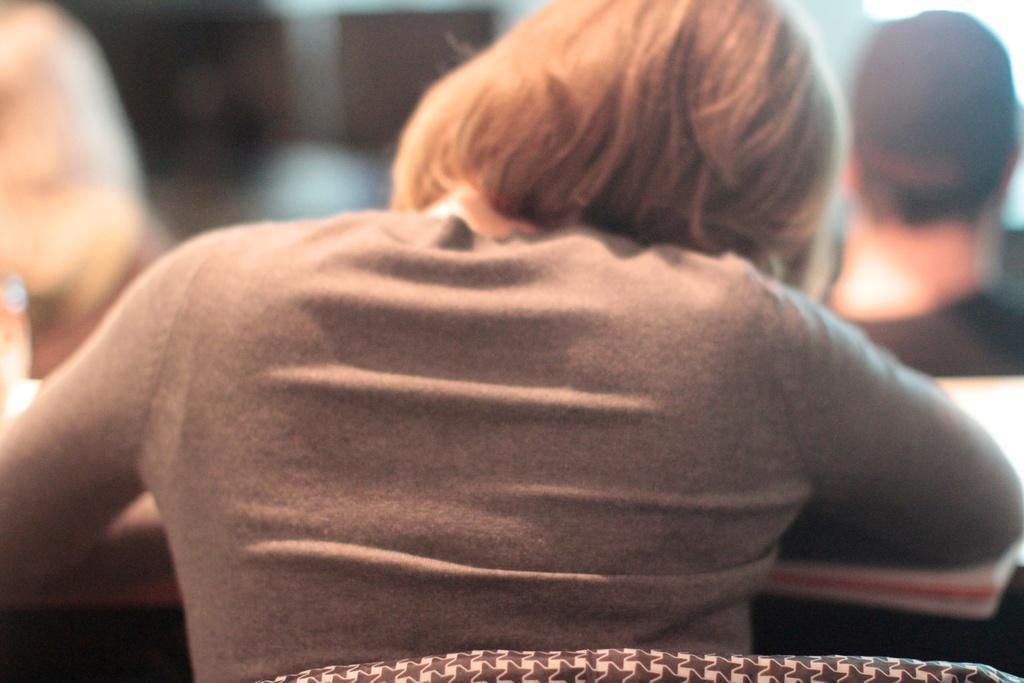Please provide a concise description of this image. Here I can see a person sitting on a chair facing towards the back side. In front of this person there is a table on which a book is placed. The background is blurred. On the right and left side of the image I can see two persons. 